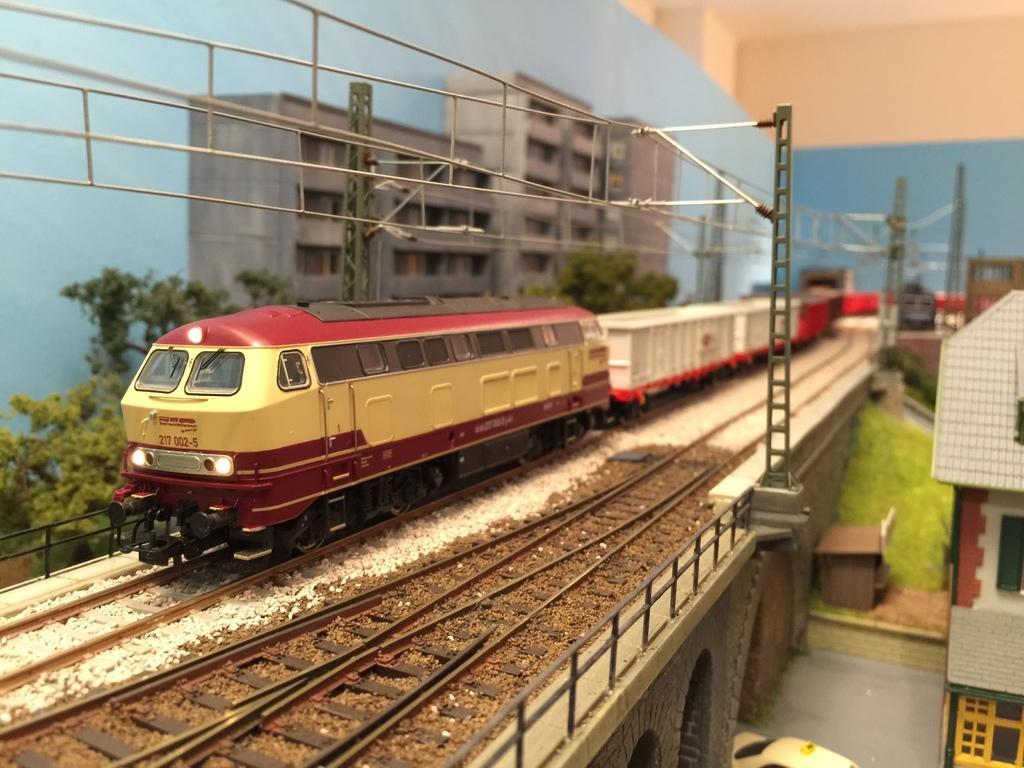Describe this image in one or two sentences. In this picture we can see the toys. On the right corner we can see the house and a vehicle and some other objects. On the left we can see a train seems to be running on the railway track. In the background we can see the trees, buildings, metal rods, cables and the sky and many other objects. 